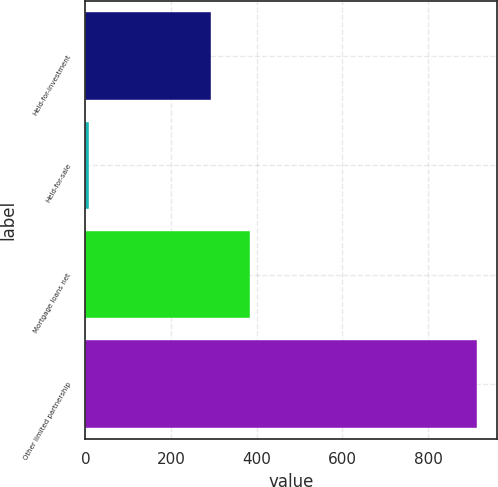Convert chart to OTSL. <chart><loc_0><loc_0><loc_500><loc_500><bar_chart><fcel>Held-for-investment<fcel>Held-for-sale<fcel>Mortgage loans net<fcel>Other limited partnership<nl><fcel>294<fcel>9<fcel>384.6<fcel>915<nl></chart> 